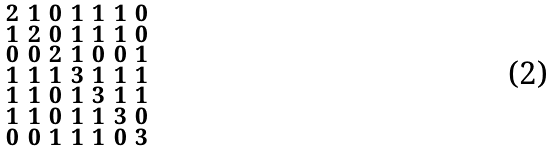Convert formula to latex. <formula><loc_0><loc_0><loc_500><loc_500>\begin{smallmatrix} 2 & 1 & 0 & 1 & 1 & 1 & 0 \\ 1 & 2 & 0 & 1 & 1 & 1 & 0 \\ 0 & 0 & 2 & 1 & 0 & 0 & 1 \\ 1 & 1 & 1 & 3 & 1 & 1 & 1 \\ 1 & 1 & 0 & 1 & 3 & 1 & 1 \\ 1 & 1 & 0 & 1 & 1 & 3 & 0 \\ 0 & 0 & 1 & 1 & 1 & 0 & 3 \end{smallmatrix}</formula> 